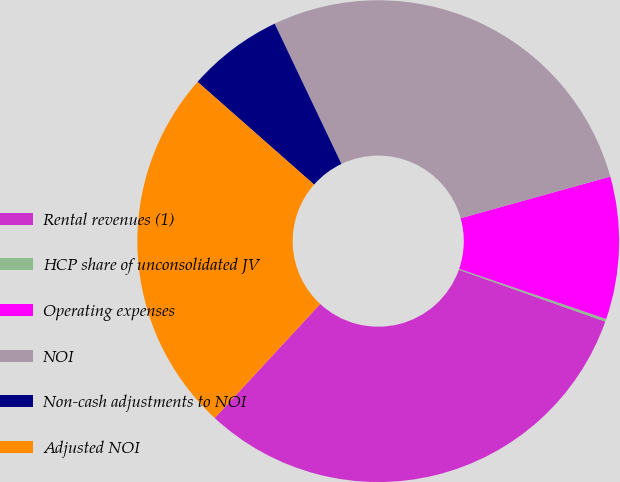Convert chart to OTSL. <chart><loc_0><loc_0><loc_500><loc_500><pie_chart><fcel>Rental revenues (1)<fcel>HCP share of unconsolidated JV<fcel>Operating expenses<fcel>NOI<fcel>Non-cash adjustments to NOI<fcel>Adjusted NOI<nl><fcel>31.46%<fcel>0.18%<fcel>9.56%<fcel>27.75%<fcel>6.43%<fcel>24.62%<nl></chart> 